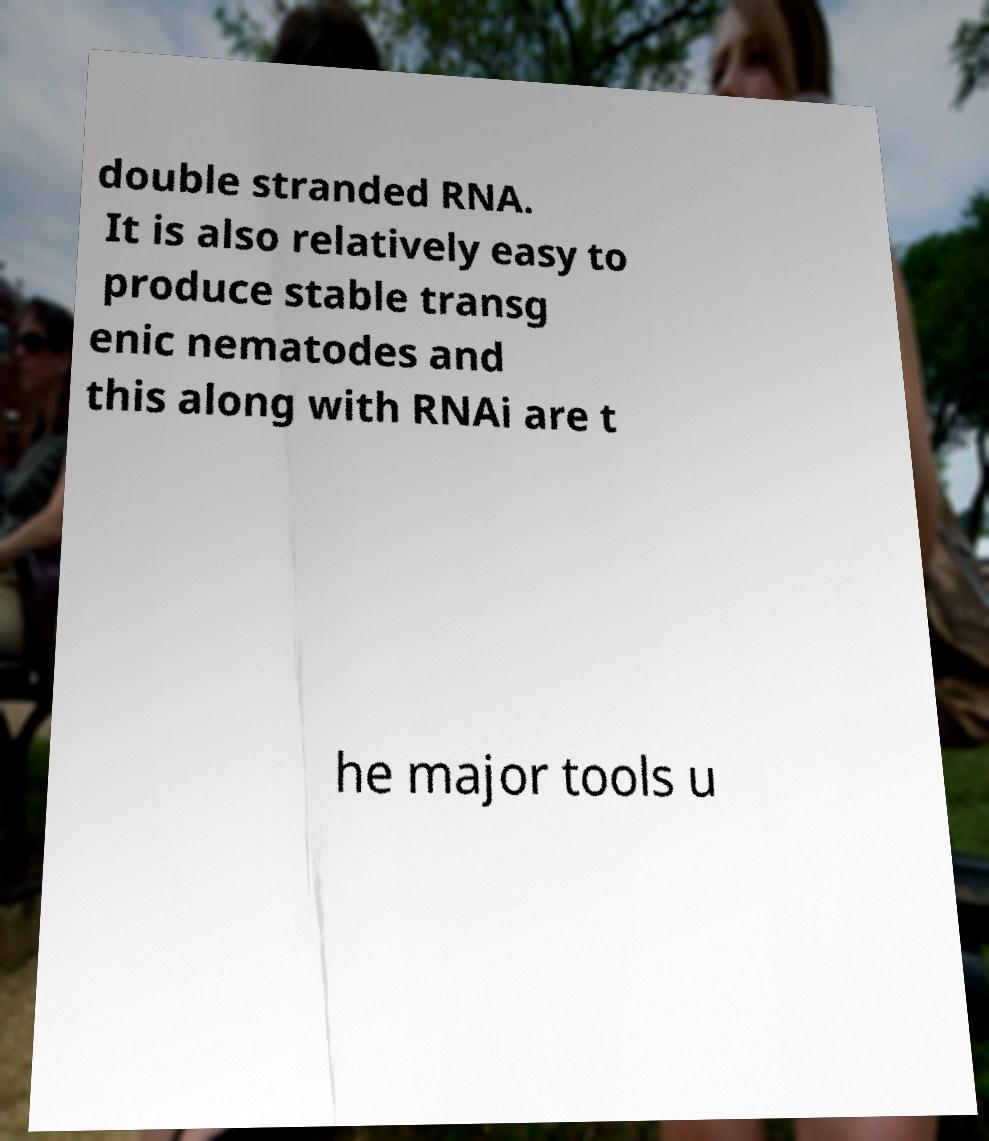For documentation purposes, I need the text within this image transcribed. Could you provide that? double stranded RNA. It is also relatively easy to produce stable transg enic nematodes and this along with RNAi are t he major tools u 